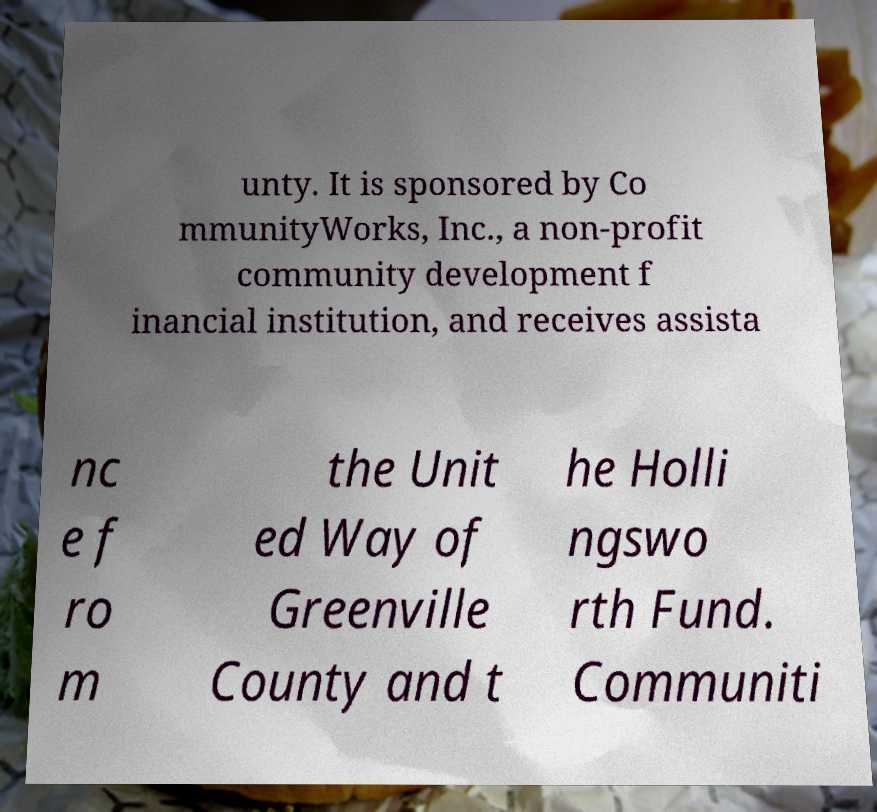I need the written content from this picture converted into text. Can you do that? unty. It is sponsored by Co mmunityWorks, Inc., a non-profit community development f inancial institution, and receives assista nc e f ro m the Unit ed Way of Greenville County and t he Holli ngswo rth Fund. Communiti 